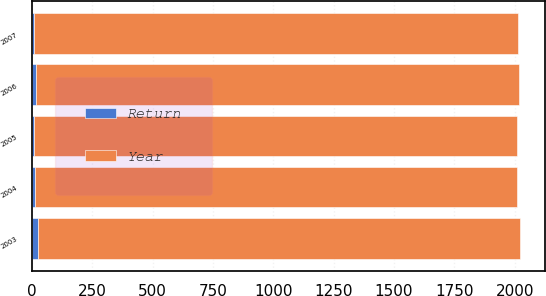Convert chart to OTSL. <chart><loc_0><loc_0><loc_500><loc_500><stacked_bar_chart><ecel><fcel>2007<fcel>2006<fcel>2005<fcel>2004<fcel>2003<nl><fcel>Return<fcel>10.3<fcel>14.9<fcel>9.8<fcel>12.6<fcel>25<nl><fcel>Year<fcel>2002<fcel>2001<fcel>2000<fcel>1999<fcel>1998<nl></chart> 